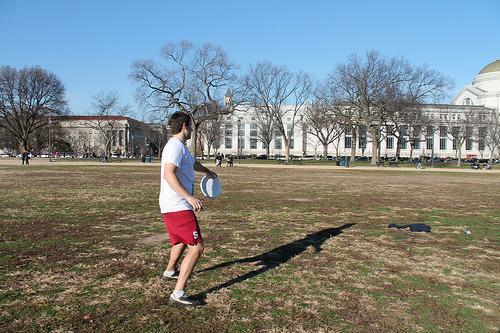How many people are in the foreground?
Give a very brief answer. 1. 